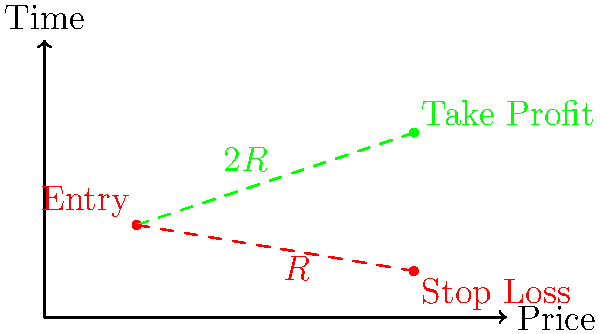As a trader aiming to improve your risk management, you're analyzing a potential trade setup. The diagram shows an entry point at $\$20$, a stop loss at $\$10$, and a take profit at $\$40$. Calculate the risk-reward ratio for this trade setup. How does this ratio align with the common trading wisdom of aiming for at least a 1:2 risk-reward ratio? To calculate the risk-reward ratio, we need to follow these steps:

1. Calculate the risk (R):
   Risk = Entry price - Stop loss price
   $R = \$20 - \$10 = \$10$

2. Calculate the reward:
   Reward = Take profit price - Entry price
   Reward = $\$40 - \$20 = \$20$

3. Express the reward in terms of R:
   Reward = $\$20 = 2R$

4. Calculate the risk-reward ratio:
   Risk : Reward = $1R : 2R = 1 : 2$

The risk-reward ratio is 1:2, which means for every $1 risked, the potential reward is $2.

This ratio aligns perfectly with the common trading wisdom of aiming for at least a 1:2 risk-reward ratio. It suggests that the trade setup has a favorable balance between potential loss and potential gain, potentially helping to offset previous losses if the trade is successful.
Answer: 1:2 